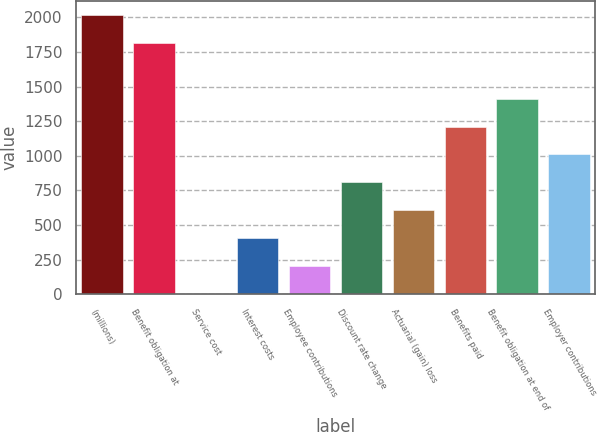<chart> <loc_0><loc_0><loc_500><loc_500><bar_chart><fcel>(millions)<fcel>Benefit obligation at<fcel>Service cost<fcel>Interest costs<fcel>Employee contributions<fcel>Discount rate change<fcel>Actuarial (gain) loss<fcel>Benefits paid<fcel>Benefit obligation at end of<fcel>Employer contributions<nl><fcel>2017<fcel>1815.56<fcel>2.6<fcel>405.48<fcel>204.04<fcel>808.36<fcel>606.92<fcel>1211.24<fcel>1412.68<fcel>1009.8<nl></chart> 